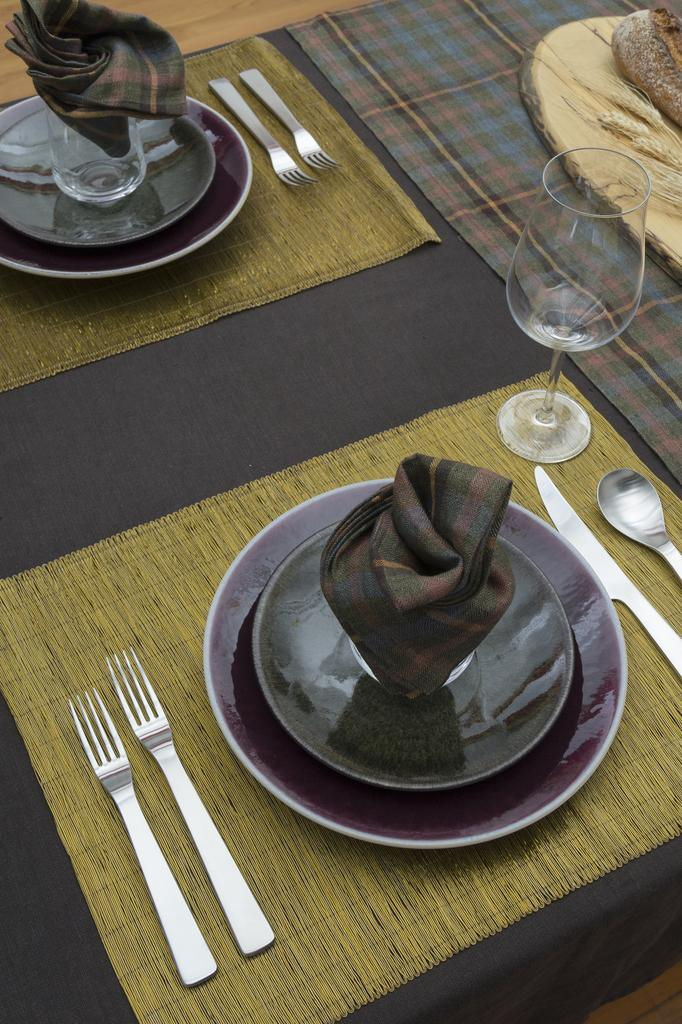What piece of furniture is present in the image? There is a table in the image. What items can be seen on the table? There are plates, spoons, glasses, forks, and kerchiefs on the table. What type of flooring is visible in the background of the image? There is a wooden floor in the background of the image. What is the view from the window in the image? There is no window present in the image, so it is not possible to describe a view. 